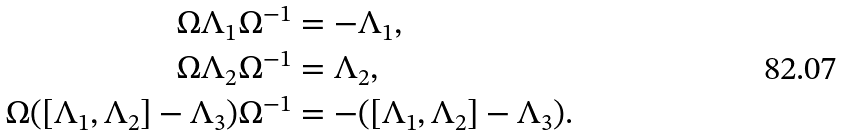<formula> <loc_0><loc_0><loc_500><loc_500>\Omega \Lambda _ { 1 } \Omega ^ { - 1 } & = - \Lambda _ { 1 } , \\ \Omega \Lambda _ { 2 } \Omega ^ { - 1 } & = \Lambda _ { 2 } , \\ \Omega ( [ \Lambda _ { 1 } , \Lambda _ { 2 } ] - \Lambda _ { 3 } ) \Omega ^ { - 1 } & = - ( [ \Lambda _ { 1 } , \Lambda _ { 2 } ] - \Lambda _ { 3 } ) .</formula> 